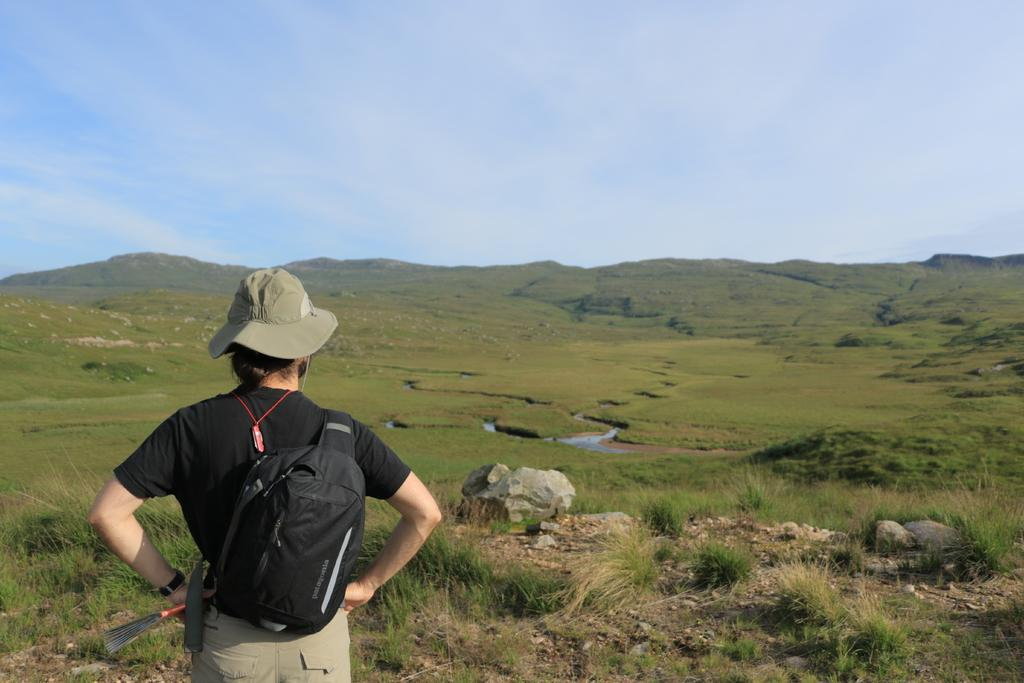What is the main subject of the image? There is a person standing in the image. What is the person wearing? The person is wearing a black shirt and cream pants. What color is the person's bag? The person has a black color bag. What can be seen in the background of the image? The background of the image includes green grass and a blue and white sky. How many branches can be seen on the person's fork in the image? There is no fork or branches present in the image. What type of pigs are visible in the background of the image? There are no pigs present in the image; the background features green grass and a blue and white sky. 